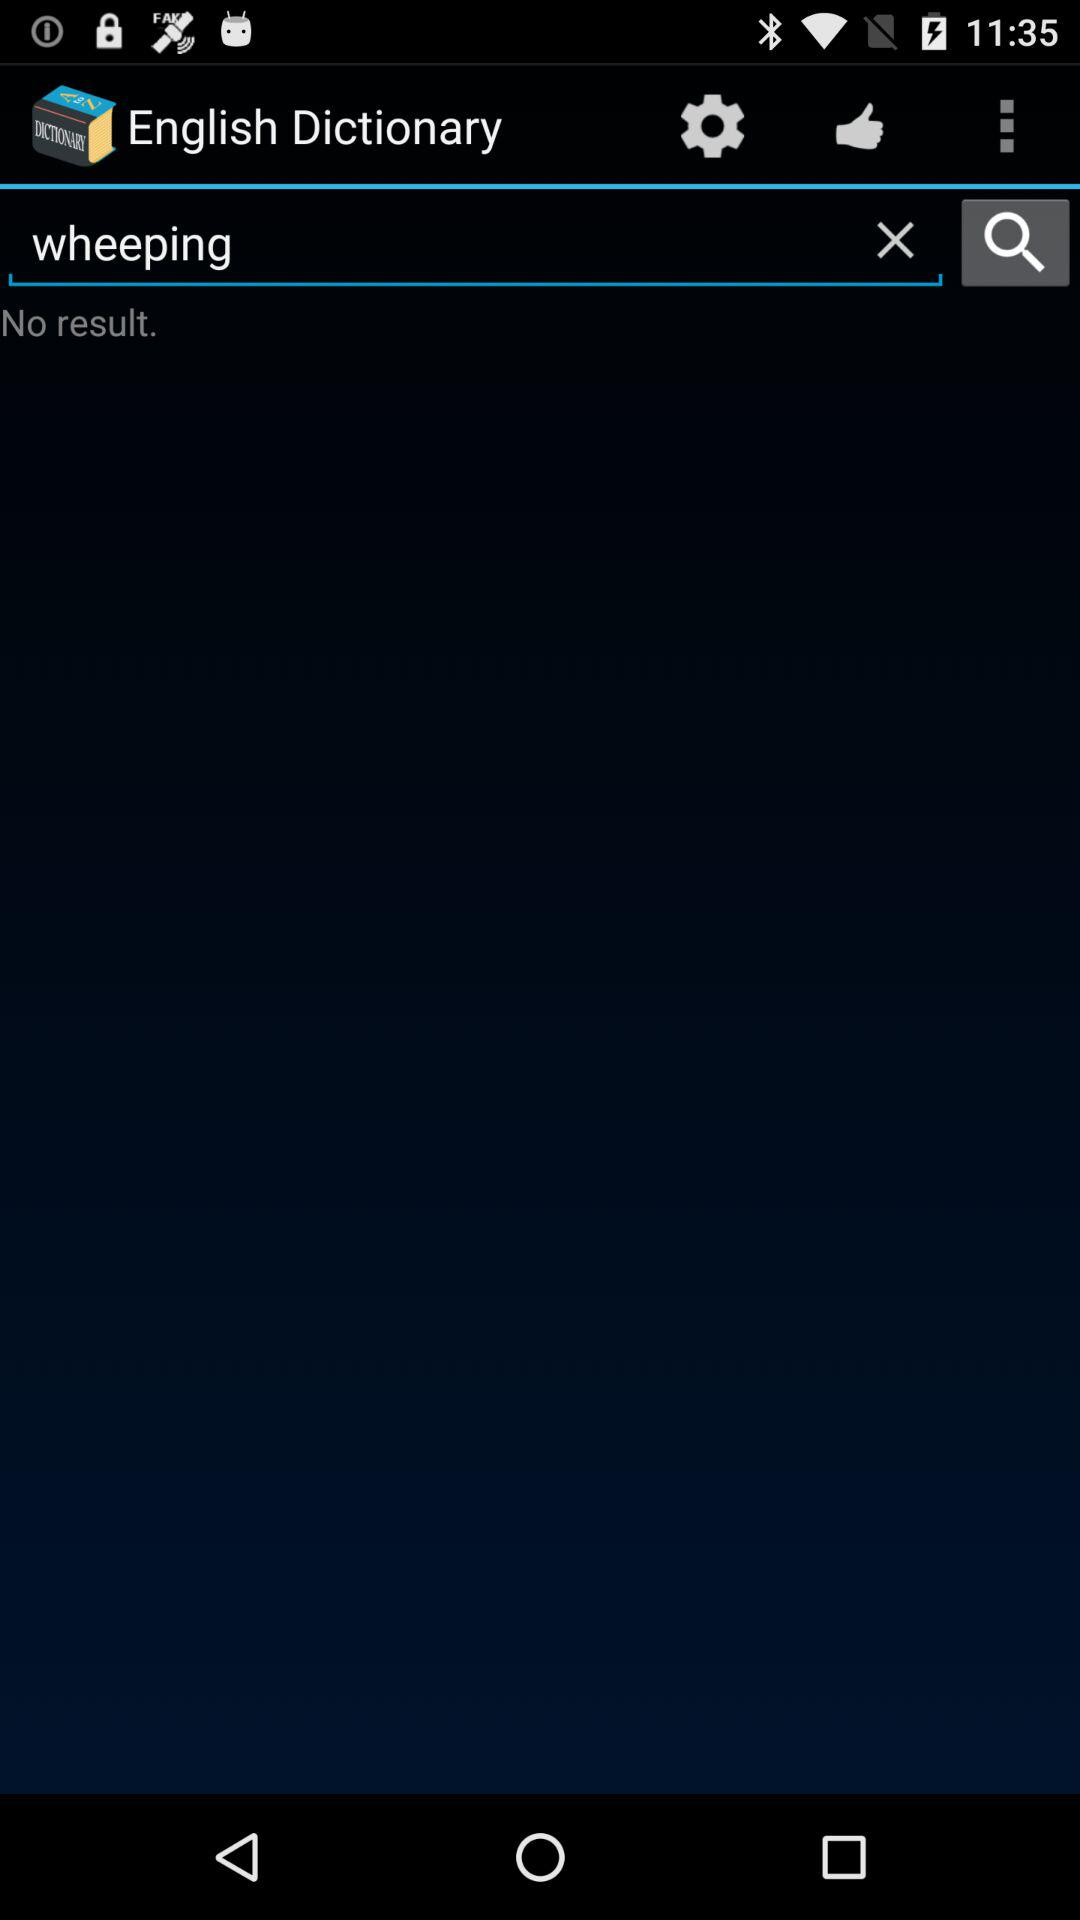What is the application name? The application name is "English Dictionary". 